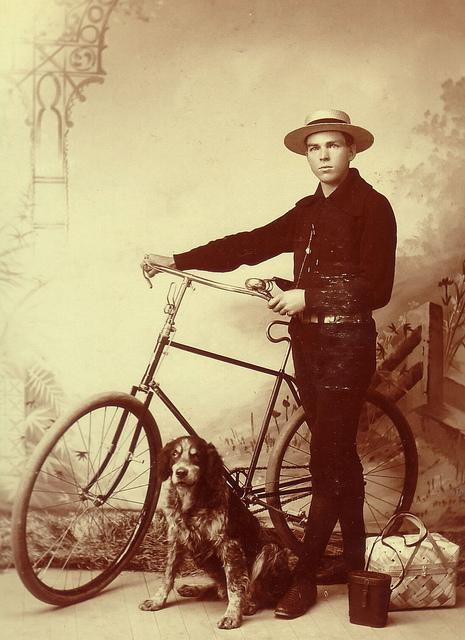Does this bike have a chain?
Keep it brief. Yes. Is the image black and white?
Answer briefly. Yes. Is this bike solidly built?
Keep it brief. Yes. 